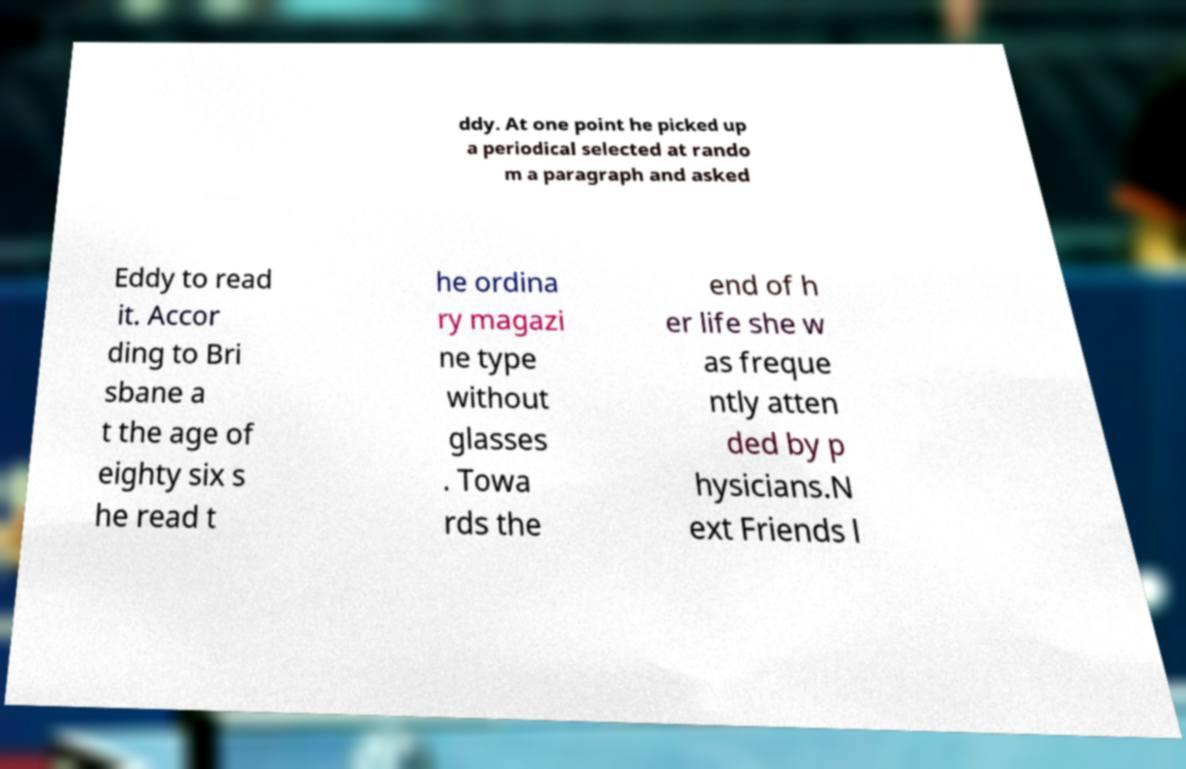Can you read and provide the text displayed in the image?This photo seems to have some interesting text. Can you extract and type it out for me? ddy. At one point he picked up a periodical selected at rando m a paragraph and asked Eddy to read it. Accor ding to Bri sbane a t the age of eighty six s he read t he ordina ry magazi ne type without glasses . Towa rds the end of h er life she w as freque ntly atten ded by p hysicians.N ext Friends l 